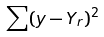Convert formula to latex. <formula><loc_0><loc_0><loc_500><loc_500>\sum ( y - Y _ { r } ) ^ { 2 }</formula> 